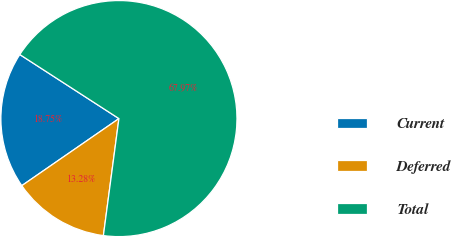Convert chart to OTSL. <chart><loc_0><loc_0><loc_500><loc_500><pie_chart><fcel>Current<fcel>Deferred<fcel>Total<nl><fcel>18.75%<fcel>13.28%<fcel>67.97%<nl></chart> 